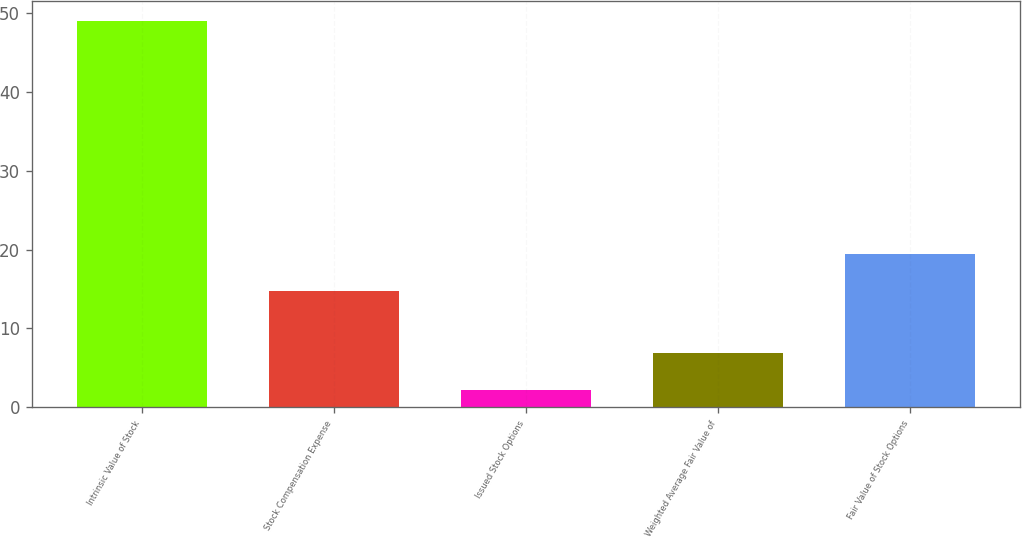<chart> <loc_0><loc_0><loc_500><loc_500><bar_chart><fcel>Intrinsic Value of Stock<fcel>Stock Compensation Expense<fcel>Issued Stock Options<fcel>Weighted Average Fair Value of<fcel>Fair Value of Stock Options<nl><fcel>49<fcel>14.8<fcel>2.2<fcel>6.88<fcel>19.48<nl></chart> 